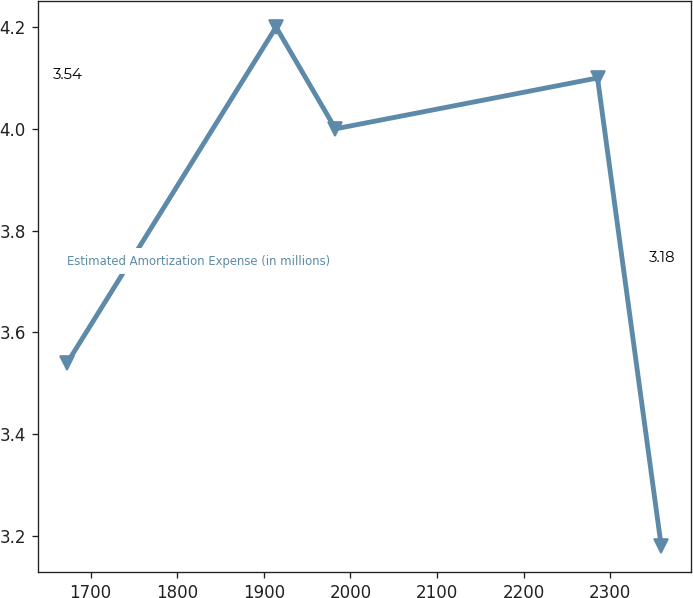Convert chart to OTSL. <chart><loc_0><loc_0><loc_500><loc_500><line_chart><ecel><fcel>Estimated Amortization Expense (in millions)<nl><fcel>1673.02<fcel>3.54<nl><fcel>1914.19<fcel>4.2<nl><fcel>1982.78<fcel>4<nl><fcel>2285.4<fcel>4.1<nl><fcel>2358.92<fcel>3.18<nl></chart> 